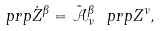Convert formula to latex. <formula><loc_0><loc_0><loc_500><loc_500>\ p r p \dot { Z } ^ { \beta } = \tilde { \mathcal { A } } ^ { \beta } _ { \nu } \ p r p Z ^ { \nu } ,</formula> 